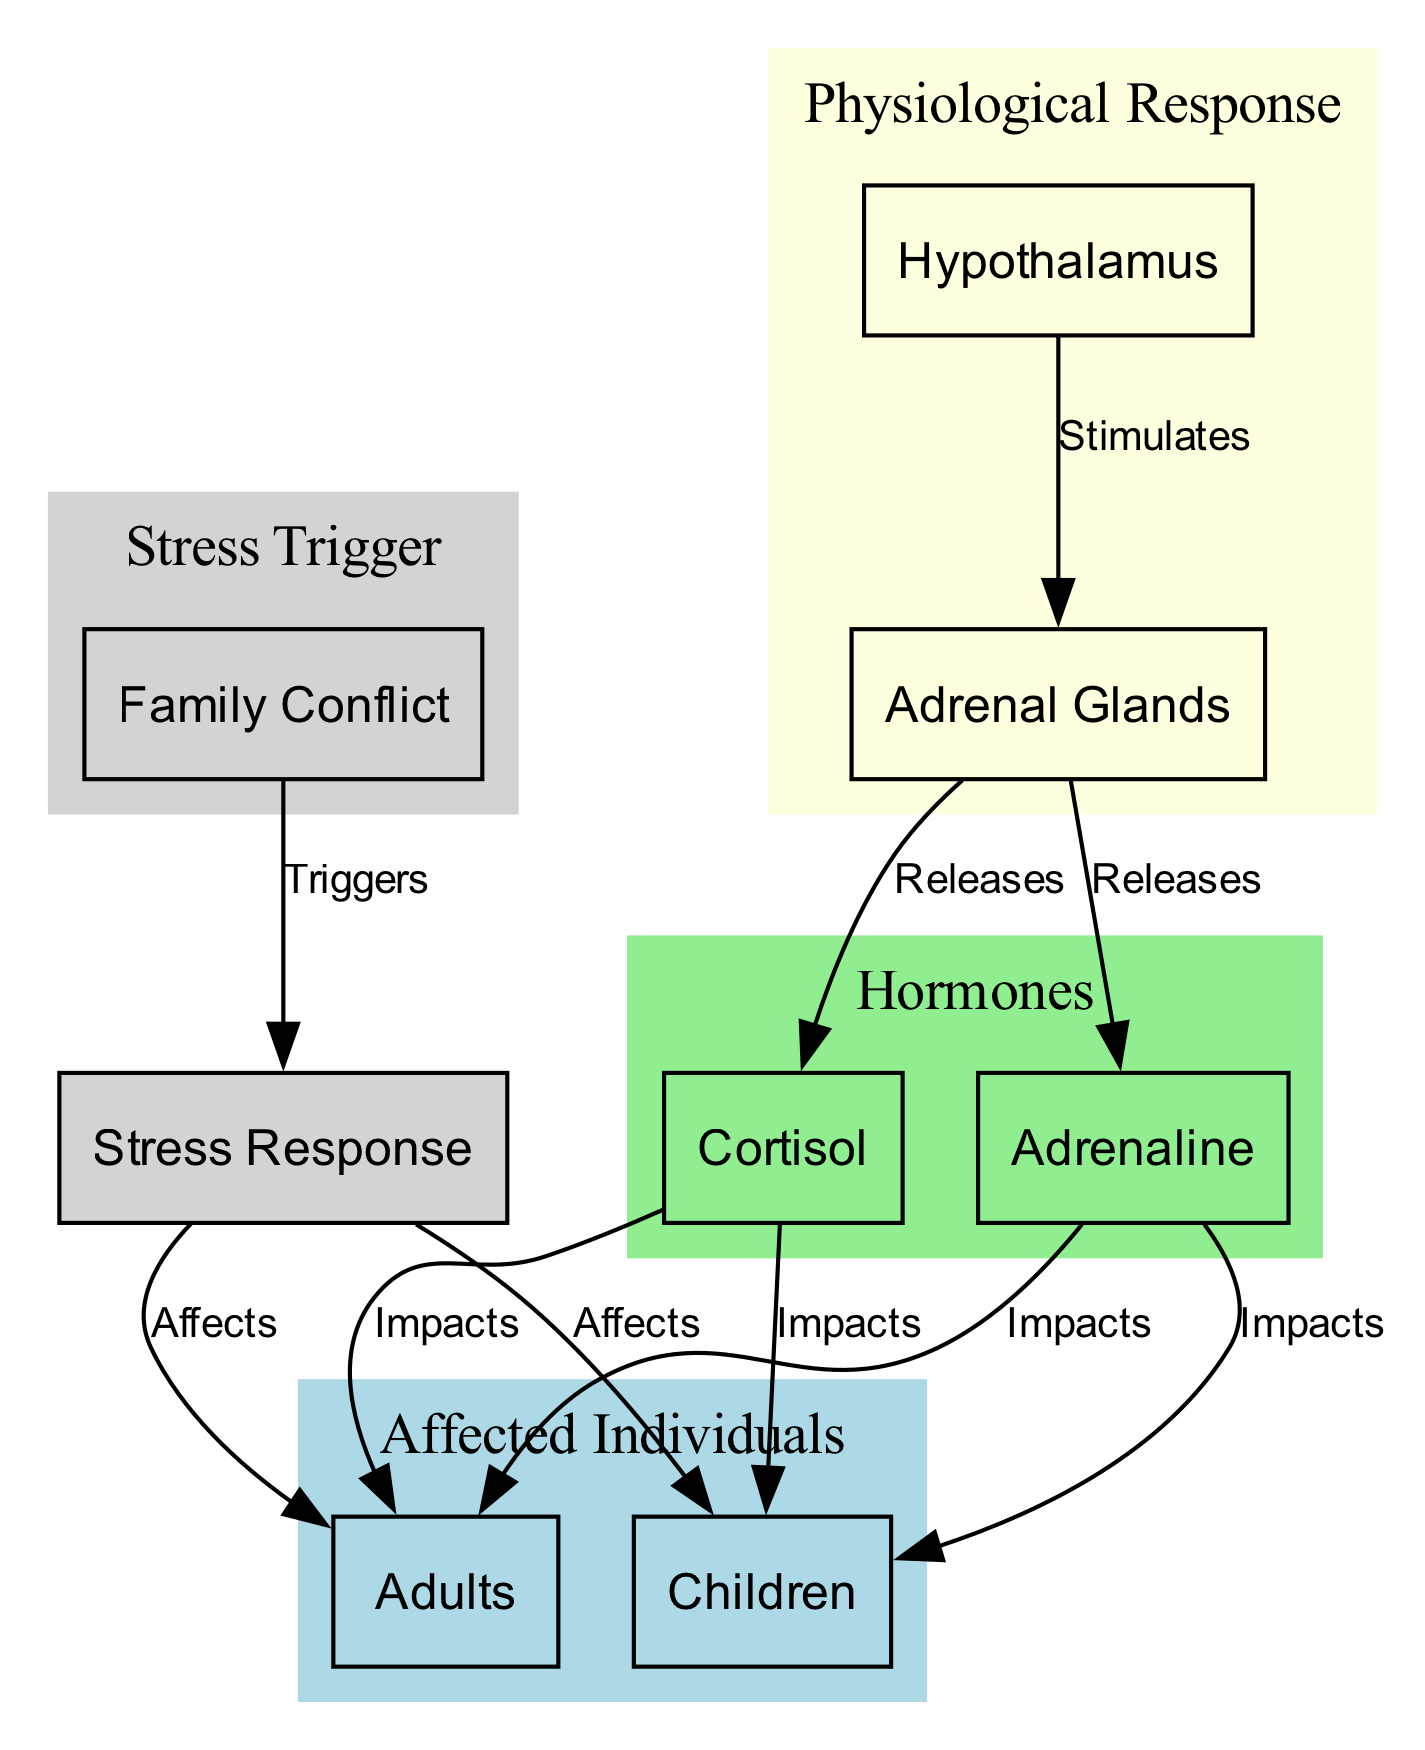What triggers the stress response? The diagram shows that "Family Conflict" is connected to "Stress Response" with the label "Triggers," indicating that family conflict is the cause of the stress response.
Answer: Family Conflict How many affected individuals are present in the diagram? The diagram identifies two affected individuals: "Adults" and "Children," which are represented as nodes. Counting them gives a total of two.
Answer: 2 What hormones are released from the adrenal glands? The diagram indicates that both "Cortisol" and "Adrenaline" are connected to "Adrenal Glands" with the label "Releases," meaning these two hormones are produced by the adrenal glands during stress.
Answer: Cortisol and Adrenaline Which part of the brain stimulates the adrenal glands? According to the diagram, the "Hypothalamus" is linked to "Adrenal Glands" with the label "Stimulates," indicating that it is the part of the brain responsible for this stimulation.
Answer: Hypothalamus What is the impact of cortisol on children? The diagram shows an edge from "Cortisol" to "Children" labeled "Impacts." This indicates that cortisol affects children, but the specific nature of that impact isn't detailed in the diagram.
Answer: Impacts What are the two physiological responses depicted in the diagram? The diagram features "Cortisol" and "Adrenaline" as hormones that are part of the physiological response to stress, connecting them as major components in the stress response system.
Answer: Cortisol and Adrenaline How does family conflict affect adults according to the diagram? "Family Conflict" connects to "Stress Response," which in turn affects "Adults," clearly showing that conflict leads to stress and subsequently impacts adults.
Answer: Affects What is the relationship between the hypothalamus and hormones in the stress response? The diagram illustrates that the "Hypothalamus" stimulates the "Adrenal Glands," which release the hormones "Cortisol" and "Adrenaline." This shows a sequential relationship involving the hypothalamus and hormonal production.
Answer: Stimulates and Releases 